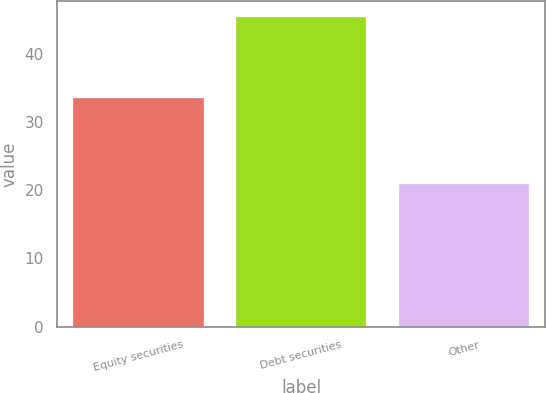Convert chart. <chart><loc_0><loc_0><loc_500><loc_500><bar_chart><fcel>Equity securities<fcel>Debt securities<fcel>Other<nl><fcel>33.5<fcel>45.5<fcel>21<nl></chart> 